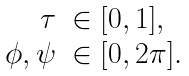Convert formula to latex. <formula><loc_0><loc_0><loc_500><loc_500>\begin{array} { r l } \tau & \in [ 0 , 1 ] , \\ \phi , \psi & \in [ 0 , 2 \pi ] . \end{array}</formula> 